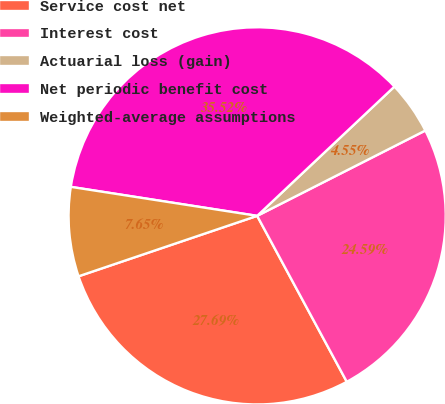Convert chart. <chart><loc_0><loc_0><loc_500><loc_500><pie_chart><fcel>Service cost net<fcel>Interest cost<fcel>Actuarial loss (gain)<fcel>Net periodic benefit cost<fcel>Weighted-average assumptions<nl><fcel>27.69%<fcel>24.59%<fcel>4.55%<fcel>35.52%<fcel>7.65%<nl></chart> 